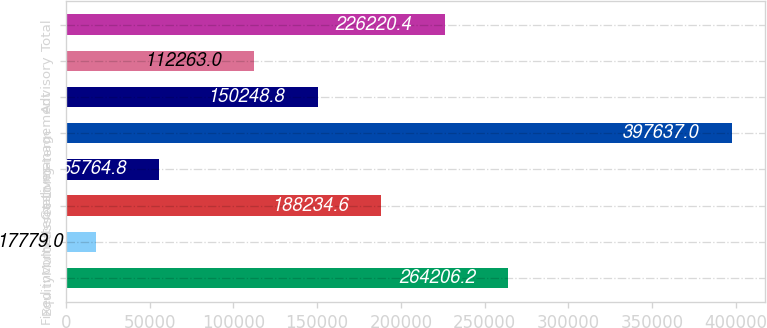Convert chart. <chart><loc_0><loc_0><loc_500><loc_500><bar_chart><fcel>Equity<fcel>Fixed income<fcel>Multi-asset<fcel>Alternatives<fcel>Long-term<fcel>Cash management<fcel>Advisory<fcel>Total<nl><fcel>264206<fcel>17779<fcel>188235<fcel>55764.8<fcel>397637<fcel>150249<fcel>112263<fcel>226220<nl></chart> 